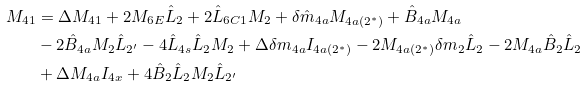<formula> <loc_0><loc_0><loc_500><loc_500>M _ { 4 1 } & = \Delta M _ { 4 1 } + 2 M _ { 6 E } \hat { L } _ { 2 } + 2 \hat { L } _ { 6 C 1 } M _ { 2 } + \delta \hat { m } _ { 4 a } M _ { 4 a ( 2 ^ { \ast } ) } + \hat { B } _ { 4 a } M _ { 4 a } \\ & - 2 \hat { B } _ { 4 a } M _ { 2 } \hat { L } _ { 2 ^ { \prime } } - 4 \hat { L } _ { 4 s } \hat { L } _ { 2 } M _ { 2 } + \Delta \delta m _ { 4 a } I _ { 4 a ( 2 ^ { \ast } ) } - 2 M _ { 4 a ( 2 ^ { \ast } ) } \delta m _ { 2 } \hat { L } _ { 2 } - 2 M _ { 4 a } \hat { B } _ { 2 } \hat { L } _ { 2 } \\ & + \Delta M _ { 4 a } I _ { 4 x } + 4 \hat { B } _ { 2 } \hat { L } _ { 2 } M _ { 2 } \hat { L } _ { 2 ^ { \prime } }</formula> 